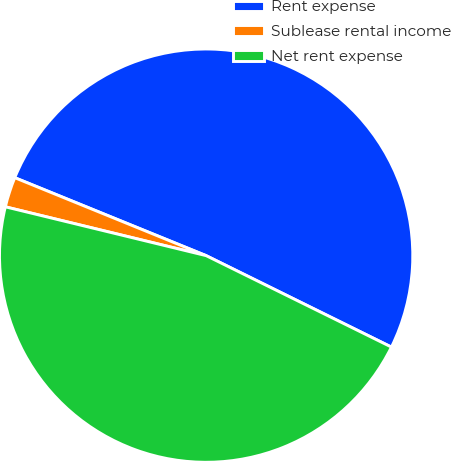Convert chart. <chart><loc_0><loc_0><loc_500><loc_500><pie_chart><fcel>Rent expense<fcel>Sublease rental income<fcel>Net rent expense<nl><fcel>51.14%<fcel>2.36%<fcel>46.5%<nl></chart> 